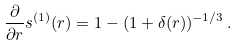Convert formula to latex. <formula><loc_0><loc_0><loc_500><loc_500>\frac { \partial } { \partial r } s ^ { ( 1 ) } ( r ) = 1 - ( 1 + \delta ( r ) ) ^ { - 1 / 3 } \, .</formula> 